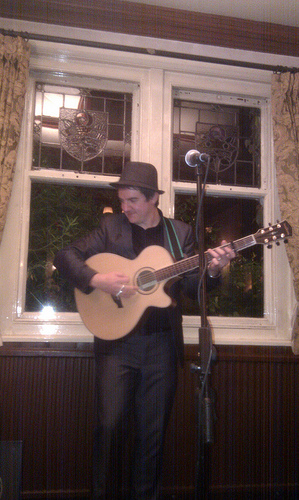<image>
Is the window in front of the man? No. The window is not in front of the man. The spatial positioning shows a different relationship between these objects. 